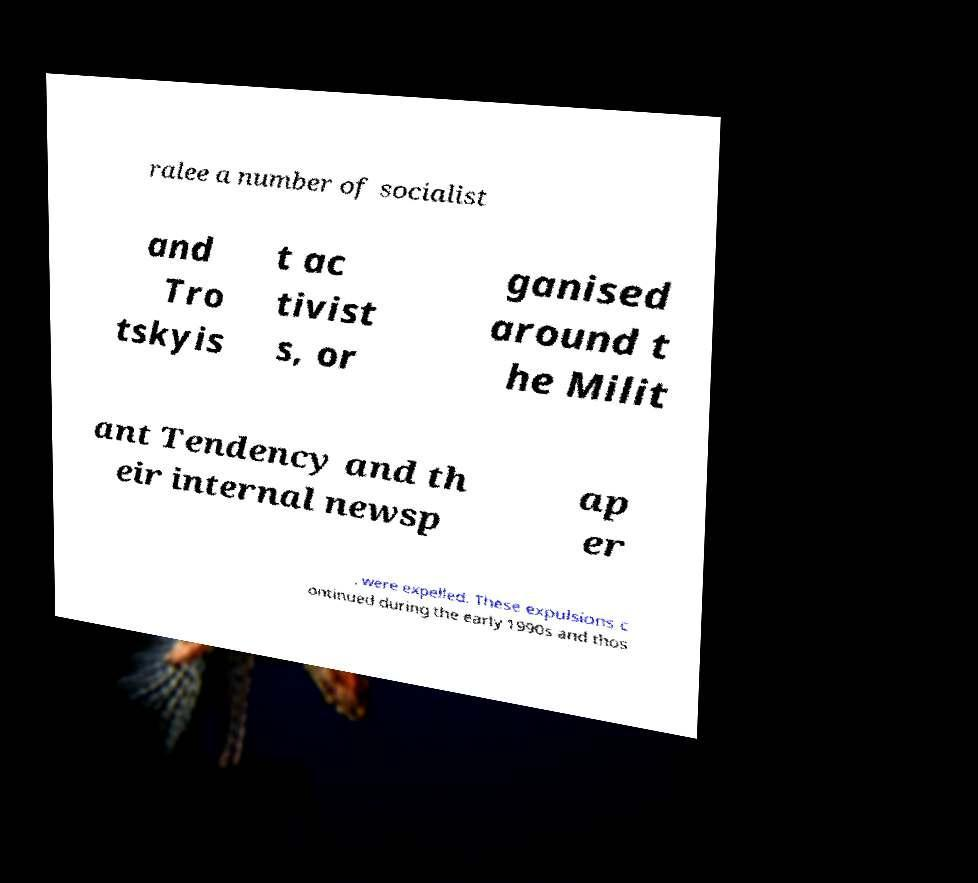Please read and relay the text visible in this image. What does it say? ralee a number of socialist and Tro tskyis t ac tivist s, or ganised around t he Milit ant Tendency and th eir internal newsp ap er , were expelled. These expulsions c ontinued during the early 1990s and thos 